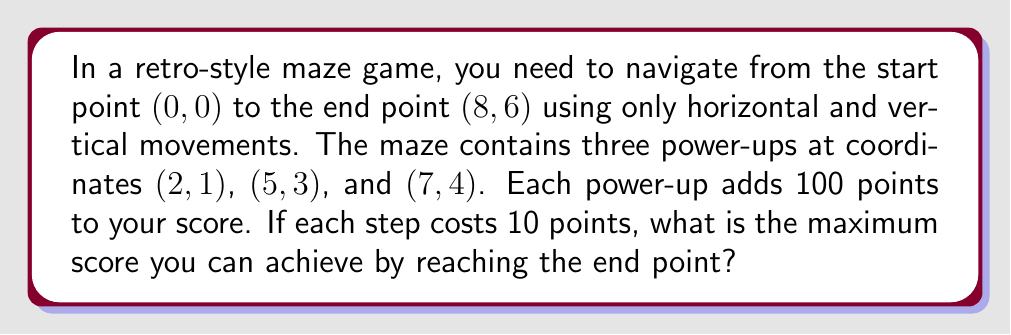Can you answer this question? Let's approach this step-by-step:

1) First, we need to calculate the minimum number of steps required to reach the end point:
   Horizontal steps: 8
   Vertical steps: 6
   Total minimum steps: $8 + 6 = 14$

2) The cost of these steps:
   $14 \times 10 = 140$ points

3) Now, let's consider the power-ups:
   - (2, 1) requires 3 steps from (0, 0)
   - (5, 3) requires 5 steps from (2, 1)
   - (7, 4) requires 3 steps from (5, 3)
   - (8, 6) requires 3 steps from (7, 4)

4) Total steps to collect all power-ups and reach the end:
   $3 + 5 + 3 + 3 = 14$ steps

5) This is the same number of steps as the direct path, so collecting all power-ups is optimal.

6) Calculate the score:
   - Cost of steps: $14 \times 10 = 140$ points
   - Gain from power-ups: $3 \times 100 = 300$ points
   - Total score: $300 - 140 = 160$ points

Therefore, the maximum achievable score is 160 points.
Answer: 160 points 